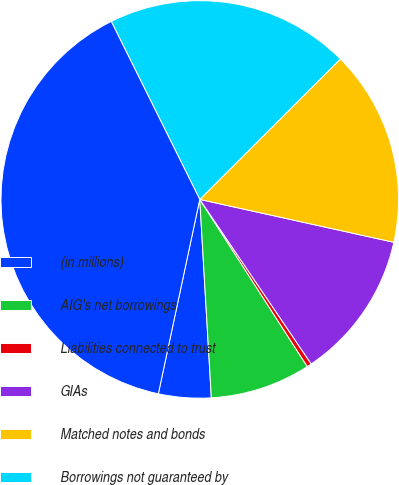<chart> <loc_0><loc_0><loc_500><loc_500><pie_chart><fcel>(in millions)<fcel>AIG's net borrowings<fcel>Liabilities connected to trust<fcel>GIAs<fcel>Matched notes and bonds<fcel>Borrowings not guaranteed by<fcel>Total debt (c)<nl><fcel>4.27%<fcel>8.17%<fcel>0.38%<fcel>12.06%<fcel>15.95%<fcel>19.85%<fcel>39.31%<nl></chart> 